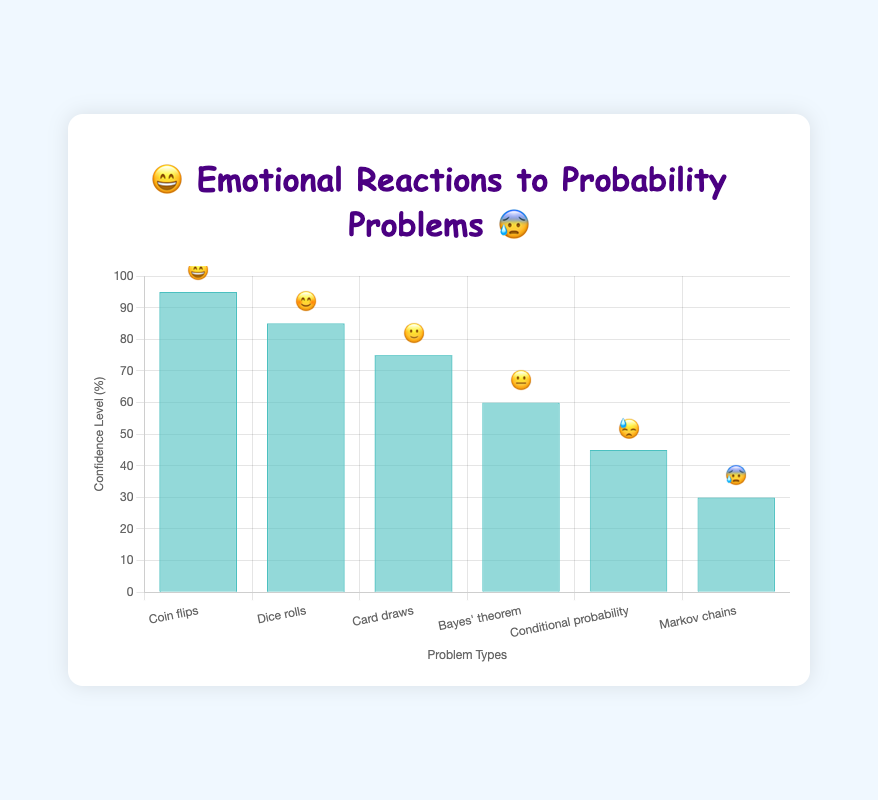What is the title of the chart? The title of the chart is displayed at the top and reads "😄 Emotional Reactions to Probability Problems 😰".
Answer: 😄 Emotional Reactions to Probability Problems 😰 Which problem type has the highest confidence level? The confidence level is represented by the height of the bars on the y-axis. The bar for "Coin flips" is the tallest, indicating the highest confidence level.
Answer: Coin flips What is the confidence level for Markov chains? The confidence level for each problem type is displayed on the y-axis. The bar for "Markov chains" has a height that corresponds to a confidence level of 30%.
Answer: 30% How many problem types are displayed in the chart? The x-axis lists each problem type, and there are six labels: "Coin flips", "Dice rolls", "Card draws", "Bayes' theorem", "Conditional probability", and "Markov chains".
Answer: 6 Which problem type has a confidence level of 60%? The bar corresponding to a confidence level of 60% is for "Bayes' theorem".
Answer: Bayes' theorem What is the range of confidence levels shown in the chart? The lowest confidence level displayed is for "Markov chains" at 30%, and the highest is for "Coin flips" at 95%. The range is calculated as 95% - 30%.
Answer: 65% What is the average confidence level across all problem types? Sum the confidence levels (95 + 85 + 75 + 60 + 45 + 30) and then divide by the number of problem types (6). The total is 390, so the average is 390/6.
Answer: 65% Which problem type has a reaction emoji of 😓? Each bar is associated with a reaction emoji. The emoji 😓 corresponds to the "Conditional probability" problem type.
Answer: Conditional probability Is the confidence level for "Dice rolls" higher or lower than "Card draws"? Compare the height of the bars and the numerical values on the y-axis. "Dice rolls" has a confidence level of 85%, which is higher than "Card draws" at 75%.
Answer: Higher How does the confidence level for "Conditional probability" compare to "Bayes' theorem"? By observing the height of the bars for both problem types, "Conditional probability" has a confidence level of 45%, which is lower than "Bayes' theorem" at 60%.
Answer: Lower 